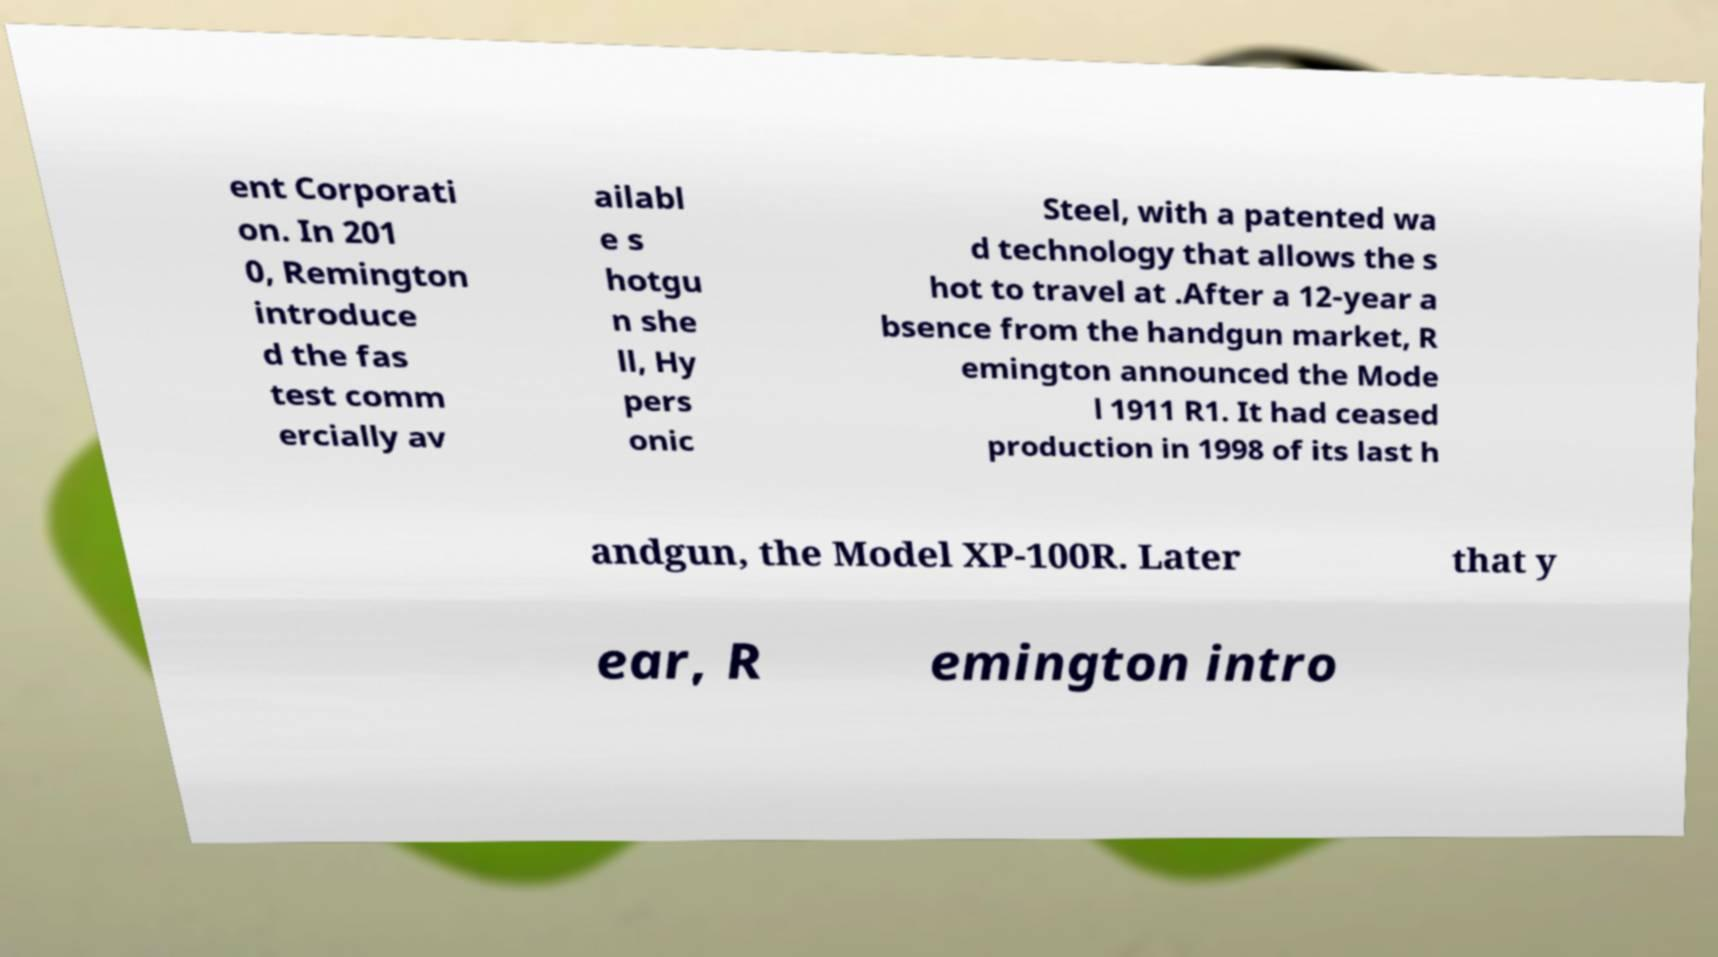Can you read and provide the text displayed in the image?This photo seems to have some interesting text. Can you extract and type it out for me? ent Corporati on. In 201 0, Remington introduce d the fas test comm ercially av ailabl e s hotgu n she ll, Hy pers onic Steel, with a patented wa d technology that allows the s hot to travel at .After a 12-year a bsence from the handgun market, R emington announced the Mode l 1911 R1. It had ceased production in 1998 of its last h andgun, the Model XP-100R. Later that y ear, R emington intro 